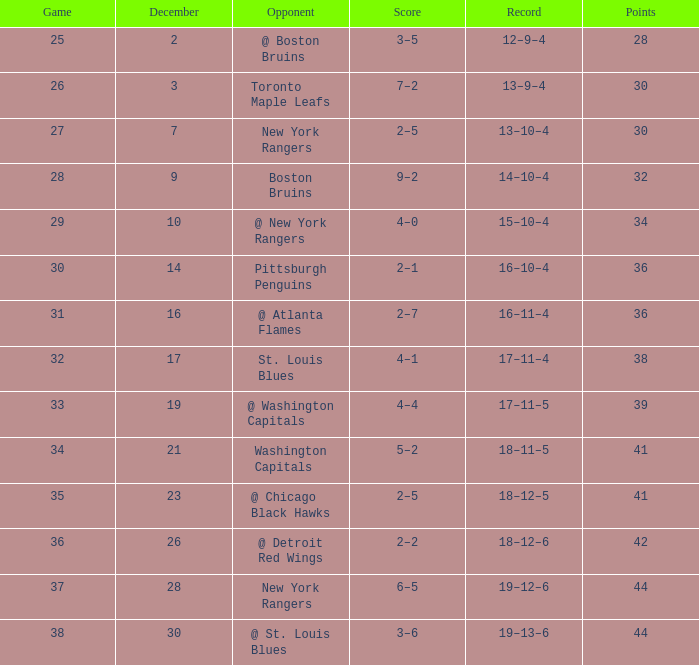In which game is there a 14-10-4 record and points under 32? None. 